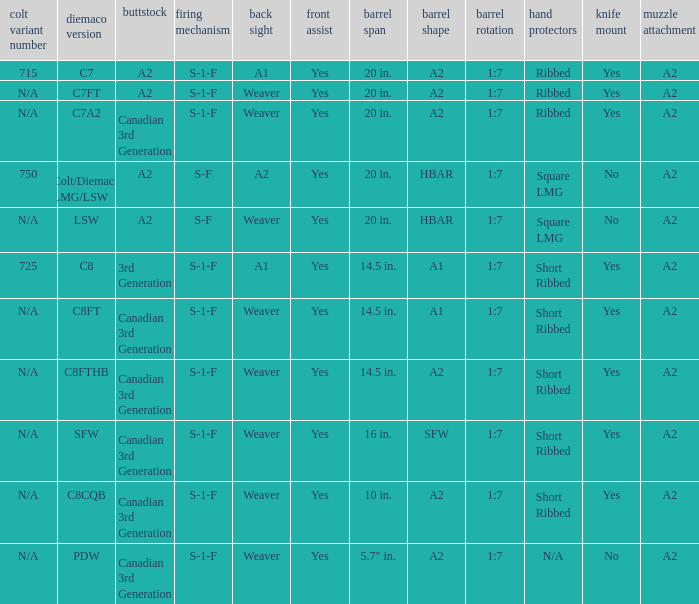Help me parse the entirety of this table. {'header': ['colt variant number', 'diemaco version', 'buttstock', 'firing mechanism', 'back sight', 'front assist', 'barrel span', 'barrel shape', 'barrel rotation', 'hand protectors', 'knife mount', 'muzzle attachment'], 'rows': [['715', 'C7', 'A2', 'S-1-F', 'A1', 'Yes', '20 in.', 'A2', '1:7', 'Ribbed', 'Yes', 'A2'], ['N/A', 'C7FT', 'A2', 'S-1-F', 'Weaver', 'Yes', '20 in.', 'A2', '1:7', 'Ribbed', 'Yes', 'A2'], ['N/A', 'C7A2', 'Canadian 3rd Generation', 'S-1-F', 'Weaver', 'Yes', '20 in.', 'A2', '1:7', 'Ribbed', 'Yes', 'A2'], ['750', 'Colt/Diemaco LMG/LSW', 'A2', 'S-F', 'A2', 'Yes', '20 in.', 'HBAR', '1:7', 'Square LMG', 'No', 'A2'], ['N/A', 'LSW', 'A2', 'S-F', 'Weaver', 'Yes', '20 in.', 'HBAR', '1:7', 'Square LMG', 'No', 'A2'], ['725', 'C8', '3rd Generation', 'S-1-F', 'A1', 'Yes', '14.5 in.', 'A1', '1:7', 'Short Ribbed', 'Yes', 'A2'], ['N/A', 'C8FT', 'Canadian 3rd Generation', 'S-1-F', 'Weaver', 'Yes', '14.5 in.', 'A1', '1:7', 'Short Ribbed', 'Yes', 'A2'], ['N/A', 'C8FTHB', 'Canadian 3rd Generation', 'S-1-F', 'Weaver', 'Yes', '14.5 in.', 'A2', '1:7', 'Short Ribbed', 'Yes', 'A2'], ['N/A', 'SFW', 'Canadian 3rd Generation', 'S-1-F', 'Weaver', 'Yes', '16 in.', 'SFW', '1:7', 'Short Ribbed', 'Yes', 'A2'], ['N/A', 'C8CQB', 'Canadian 3rd Generation', 'S-1-F', 'Weaver', 'Yes', '10 in.', 'A2', '1:7', 'Short Ribbed', 'Yes', 'A2'], ['N/A', 'PDW', 'Canadian 3rd Generation', 'S-1-F', 'Weaver', 'Yes', '5.7" in.', 'A2', '1:7', 'N/A', 'No', 'A2']]} Which Barrel twist has a Stock of canadian 3rd generation and a Hand guards of short ribbed? 1:7, 1:7, 1:7, 1:7. 